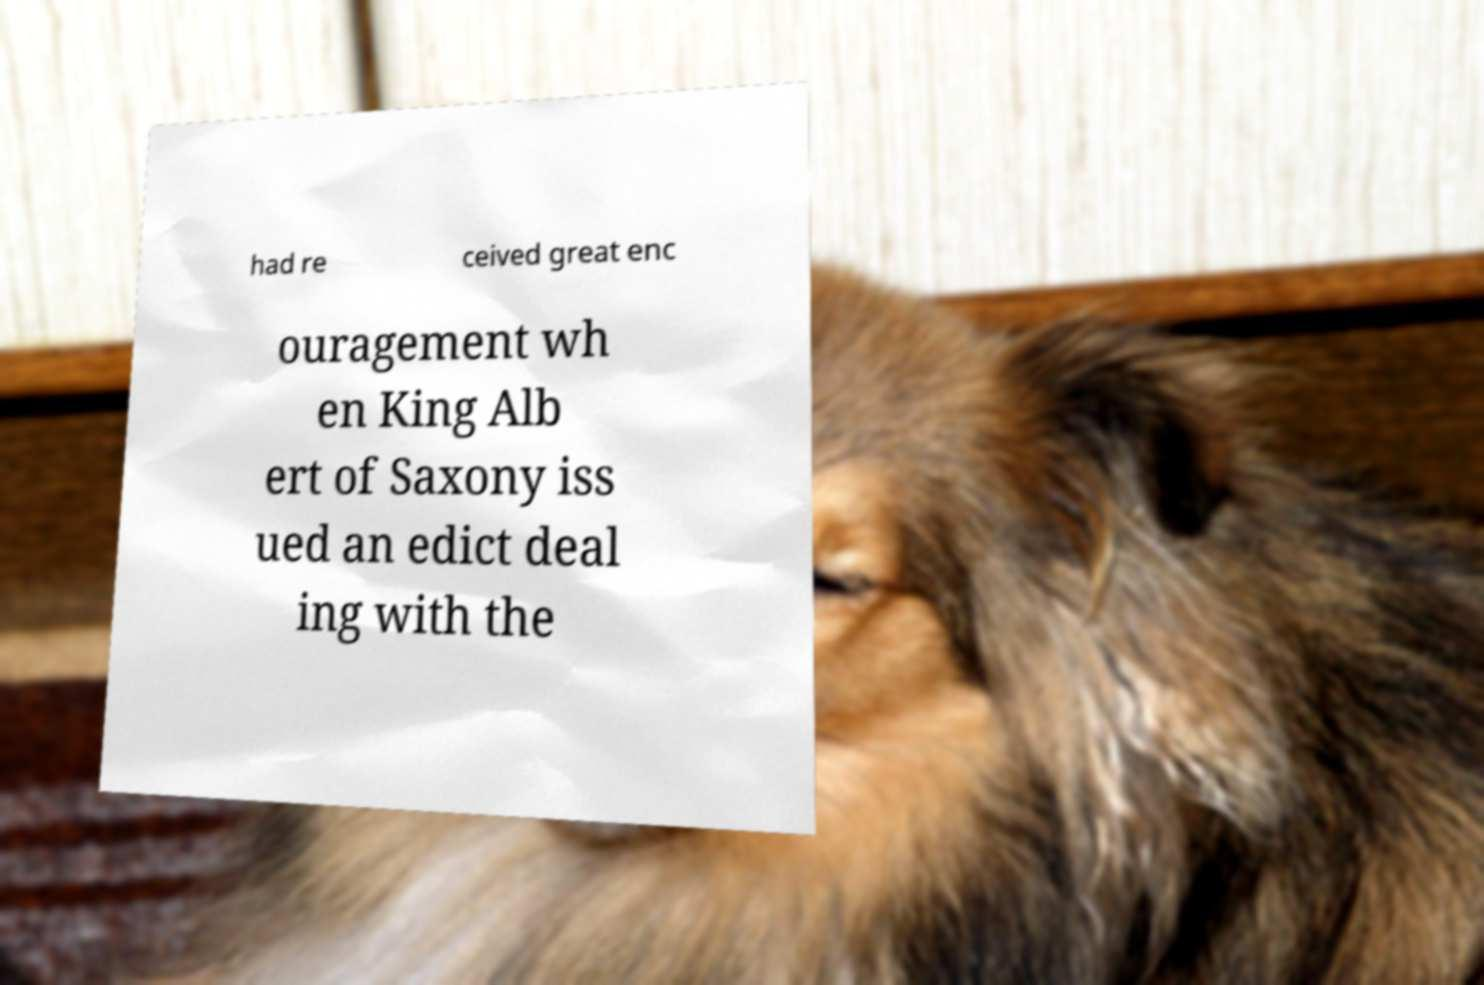Can you read and provide the text displayed in the image?This photo seems to have some interesting text. Can you extract and type it out for me? had re ceived great enc ouragement wh en King Alb ert of Saxony iss ued an edict deal ing with the 